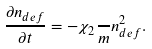Convert formula to latex. <formula><loc_0><loc_0><loc_500><loc_500>\frac { \partial n _ { d e f } } { \partial t } = - \chi _ { 2 } \frac { } { m } n _ { d e f } ^ { 2 } .</formula> 